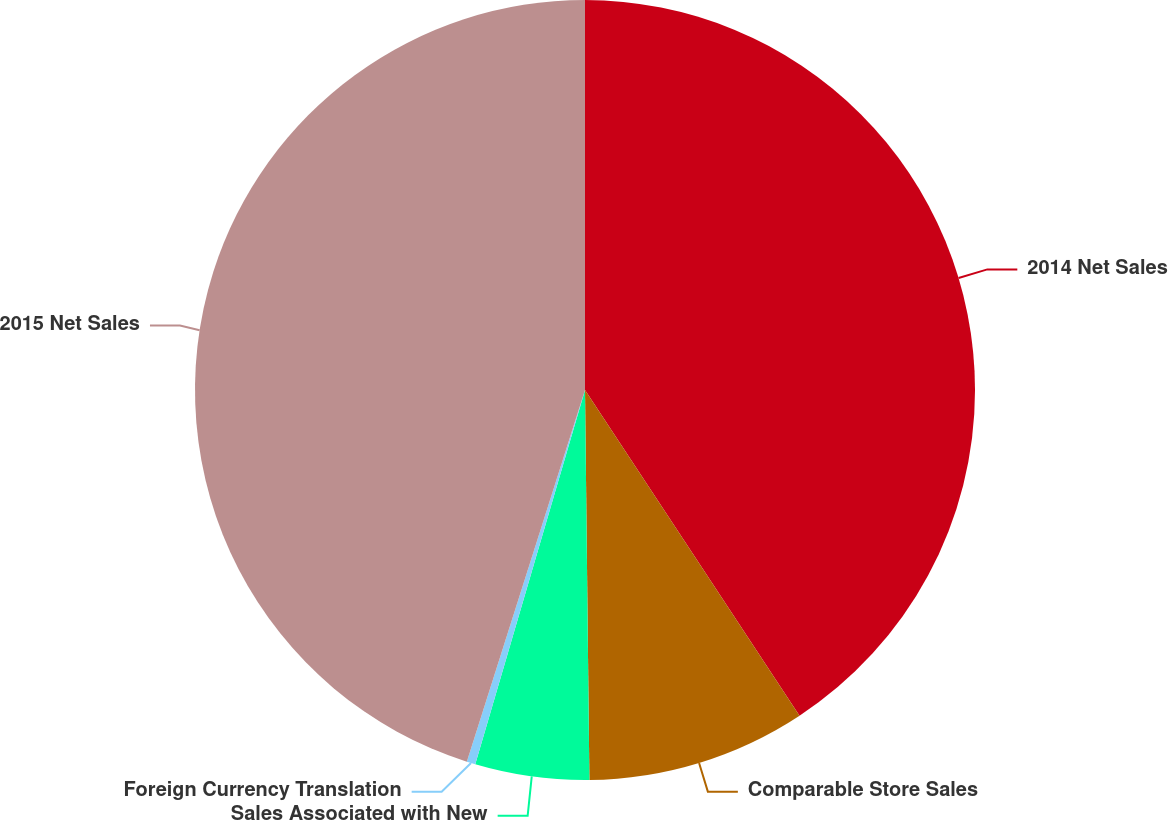<chart> <loc_0><loc_0><loc_500><loc_500><pie_chart><fcel>2014 Net Sales<fcel>Comparable Store Sales<fcel>Sales Associated with New<fcel>Foreign Currency Translation<fcel>2015 Net Sales<nl><fcel>40.73%<fcel>9.09%<fcel>4.72%<fcel>0.36%<fcel>45.1%<nl></chart> 